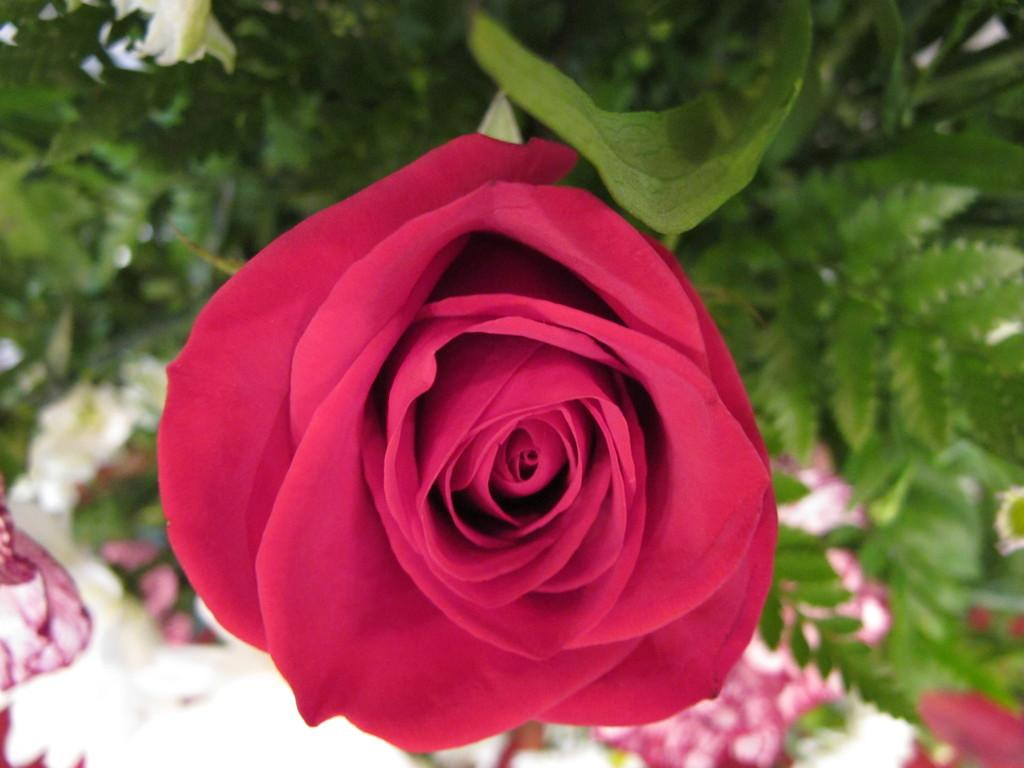What type of flower is in the image? There is a pinkish red color rose in the image. What part of the rose is visible in the image? The rose has a leaf. What else can be seen in the background of the image? There are leaves visible in the background of the image. What type of cake is being served in the image? There is no cake present in the image; it features a rose with a leaf and background leaves. 